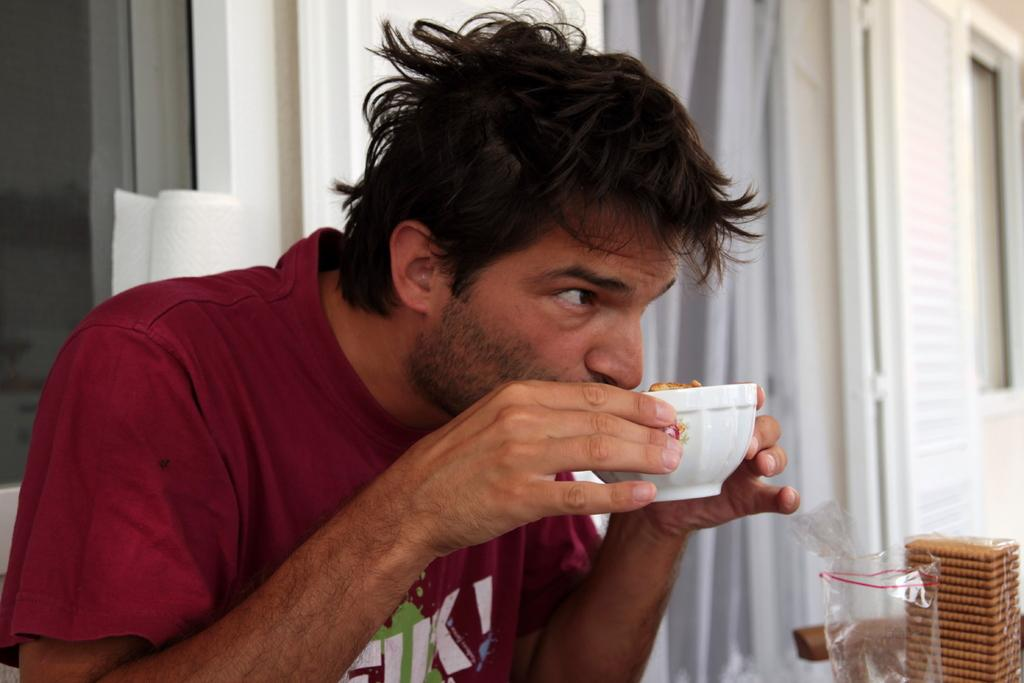What is the main subject of the image? There is a person sitting in the center of the image. What is the person holding in the image? The person is holding a cup. What can be seen in the background of the image? There is a wall, a window with a curtain, plastic covers, biscuits, and a few other objects in the background of the image. What type of cheese is being sold at the store in the image? There is no store or cheese present in the image. Can you describe the person's smile in the image? The provided facts do not mention the person's facial expression, so we cannot determine if they are smiling or not. 